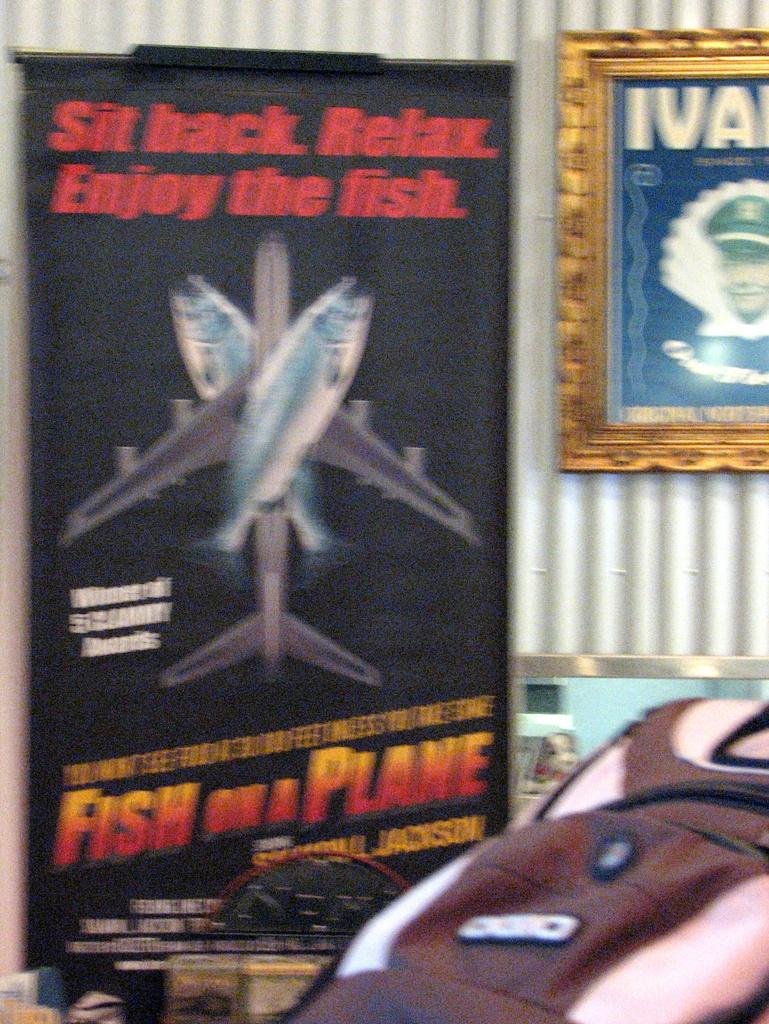Provide a one-sentence caption for the provided image. A Fish on a plane movie poster hanging next to a picture. 